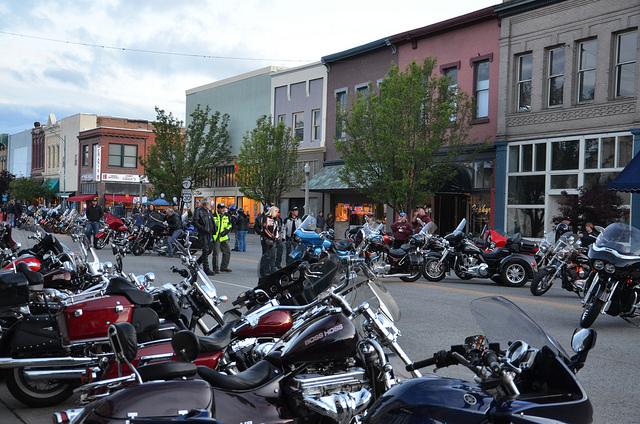HOW are the skies?
Concise answer only. Cloudy. Are there cars?
Be succinct. No. Is a fast food restaurant visible in this picture?
Keep it brief. No. Do trees line the sidewalk?
Be succinct. Yes. Are these recent models?
Be succinct. Yes. 